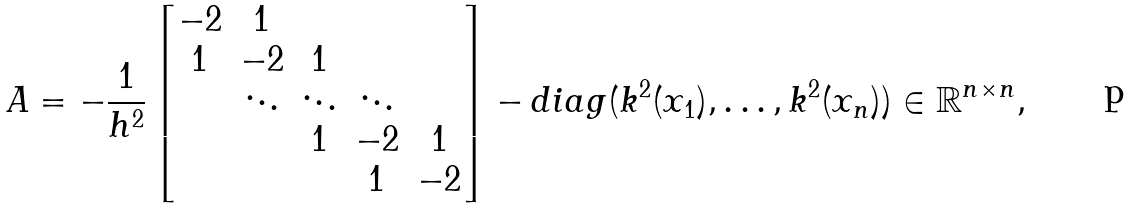Convert formula to latex. <formula><loc_0><loc_0><loc_500><loc_500>A = - \frac { 1 } { h ^ { 2 } } \begin{bmatrix} - 2 & 1 & & & \\ 1 & - 2 & 1 & & \\ & \ddots & \ddots & \ddots \\ & & 1 & - 2 & 1 \\ & & & 1 & - 2 \end{bmatrix} - d i a g ( k ^ { 2 } ( x _ { 1 } ) , \dots , k ^ { 2 } ( x _ { n } ) ) \in \mathbb { R } ^ { n \times n } ,</formula> 